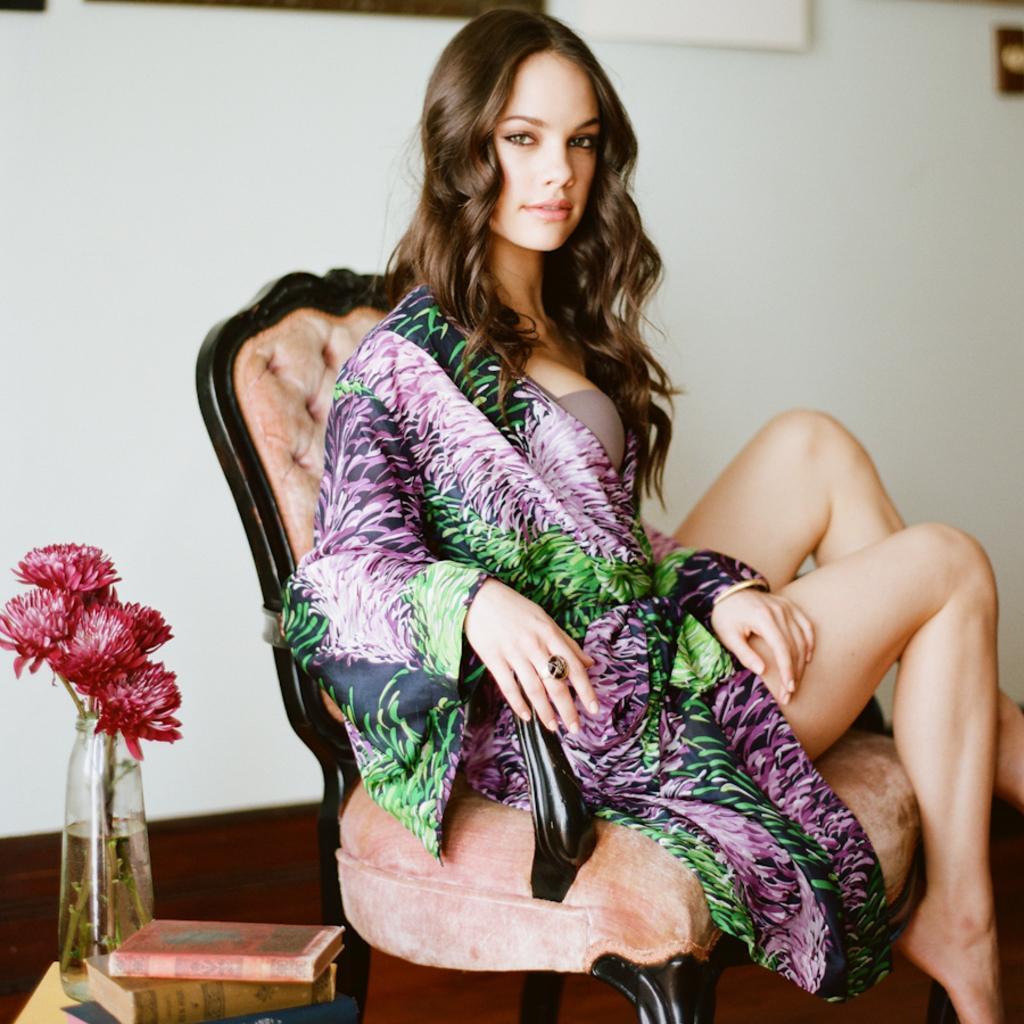How would you summarize this image in a sentence or two? In the image we can see a sitting, wearing clothes, finger ring, bracelet and she is smiling. She is sitting on a chair. Here we can see the flowers in the bottle and there is even water in the bottle. Here we can see the books and the wall. 